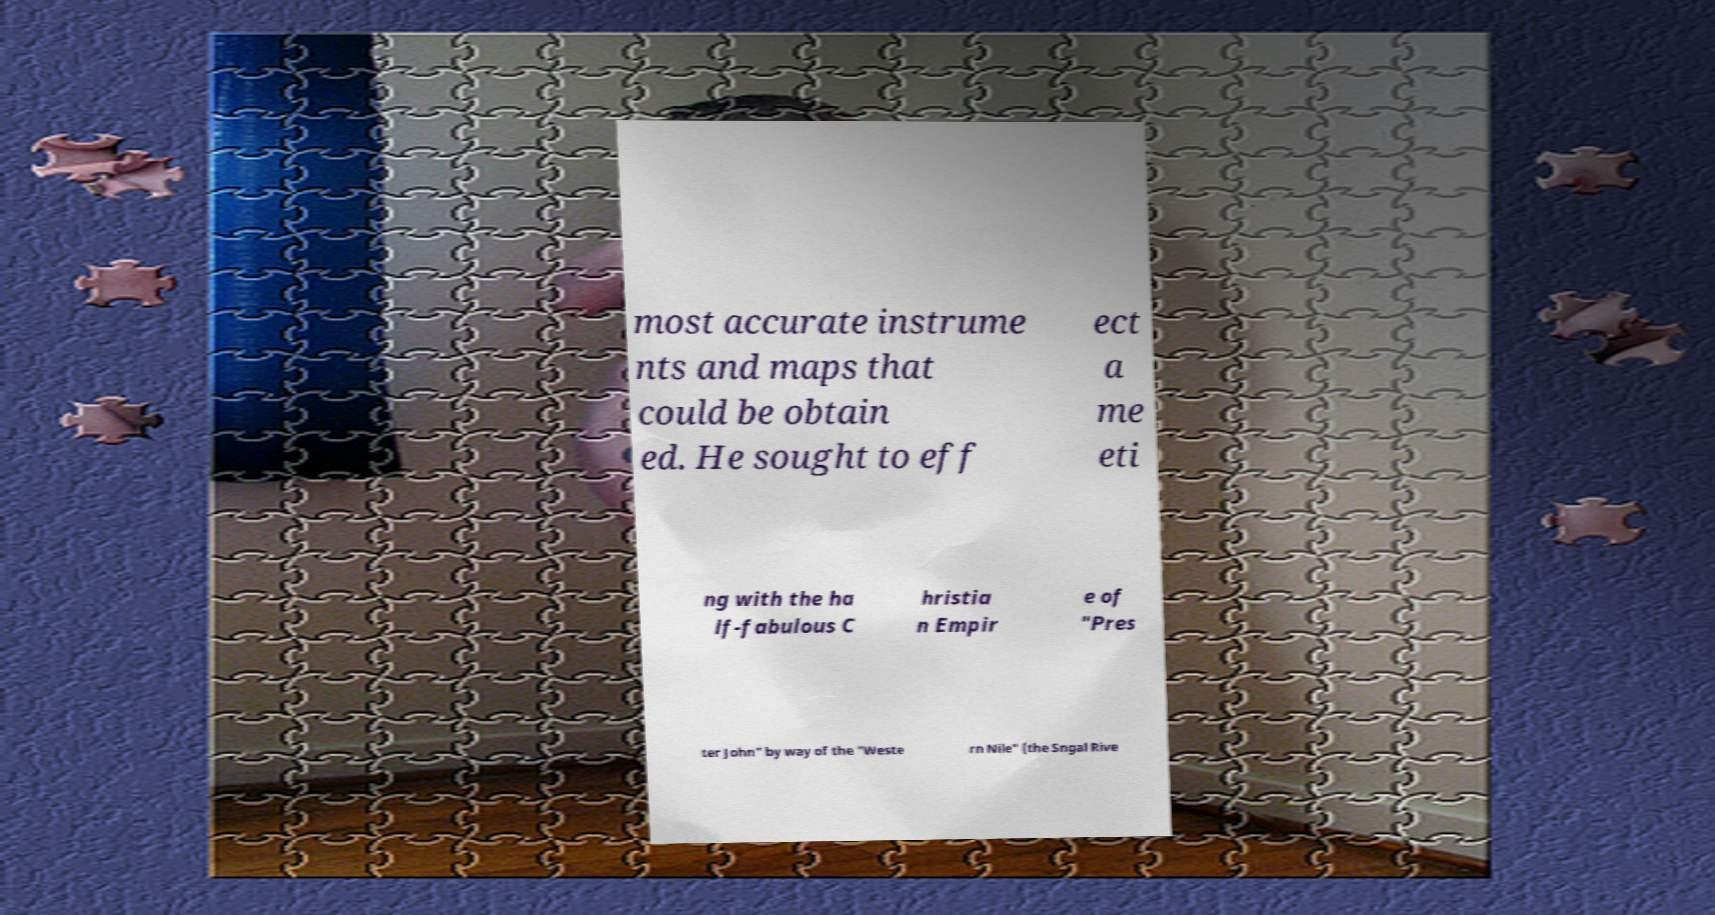Can you read and provide the text displayed in the image?This photo seems to have some interesting text. Can you extract and type it out for me? most accurate instrume nts and maps that could be obtain ed. He sought to eff ect a me eti ng with the ha lf-fabulous C hristia n Empir e of "Pres ter John" by way of the "Weste rn Nile" (the Sngal Rive 